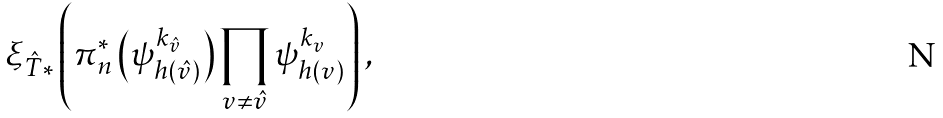Convert formula to latex. <formula><loc_0><loc_0><loc_500><loc_500>{ \xi _ { \hat { T } } } _ { * } \left ( \pi _ { n } ^ { \ast } \left ( \psi _ { h ( \hat { v } ) } ^ { k _ { \hat { v } } } \right ) \prod _ { v \not = \hat { v } } \psi _ { h ( v ) } ^ { k _ { v } } \right ) ,</formula> 